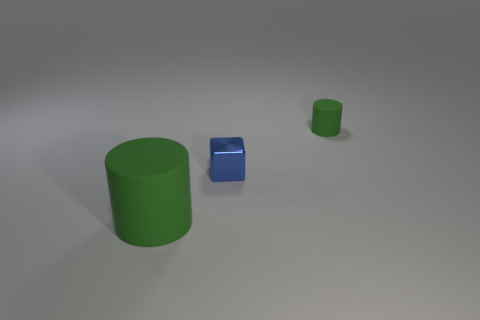Are there any other things that are the same material as the blue block?
Provide a short and direct response. No. What number of things are green matte cylinders behind the big cylinder or rubber cylinders behind the tiny blue cube?
Provide a short and direct response. 1. Is there anything else that has the same color as the block?
Your response must be concise. No. What is the color of the matte cylinder behind the small object to the left of the matte thing that is behind the blue metal object?
Provide a succinct answer. Green. How big is the green rubber cylinder to the right of the green rubber thing that is in front of the tiny rubber thing?
Give a very brief answer. Small. There is a object that is on the left side of the tiny green cylinder and behind the big green object; what material is it?
Ensure brevity in your answer.  Metal. There is a blue thing; does it have the same size as the matte object right of the big green cylinder?
Offer a very short reply. Yes. Are any big green matte cylinders visible?
Provide a short and direct response. Yes. There is a tiny thing that is the same shape as the large green thing; what is it made of?
Provide a succinct answer. Rubber. There is a blue block left of the green matte thing behind the big cylinder to the left of the blue metal thing; how big is it?
Your answer should be compact. Small. 